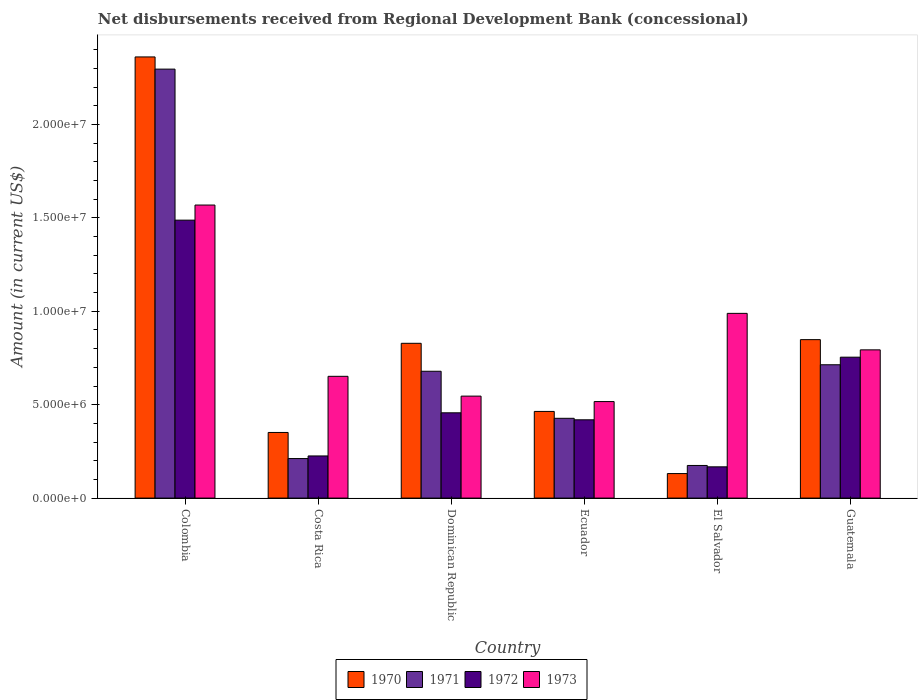How many different coloured bars are there?
Your answer should be very brief. 4. Are the number of bars per tick equal to the number of legend labels?
Your answer should be very brief. Yes. How many bars are there on the 6th tick from the left?
Ensure brevity in your answer.  4. What is the label of the 4th group of bars from the left?
Your answer should be compact. Ecuador. What is the amount of disbursements received from Regional Development Bank in 1972 in Ecuador?
Your response must be concise. 4.19e+06. Across all countries, what is the maximum amount of disbursements received from Regional Development Bank in 1971?
Keep it short and to the point. 2.30e+07. Across all countries, what is the minimum amount of disbursements received from Regional Development Bank in 1971?
Offer a very short reply. 1.75e+06. In which country was the amount of disbursements received from Regional Development Bank in 1970 minimum?
Offer a very short reply. El Salvador. What is the total amount of disbursements received from Regional Development Bank in 1973 in the graph?
Make the answer very short. 5.07e+07. What is the difference between the amount of disbursements received from Regional Development Bank in 1972 in Colombia and that in Dominican Republic?
Offer a very short reply. 1.03e+07. What is the difference between the amount of disbursements received from Regional Development Bank in 1971 in Ecuador and the amount of disbursements received from Regional Development Bank in 1972 in Dominican Republic?
Provide a short and direct response. -2.94e+05. What is the average amount of disbursements received from Regional Development Bank in 1971 per country?
Your response must be concise. 7.50e+06. What is the difference between the amount of disbursements received from Regional Development Bank of/in 1971 and amount of disbursements received from Regional Development Bank of/in 1970 in Colombia?
Make the answer very short. -6.52e+05. In how many countries, is the amount of disbursements received from Regional Development Bank in 1972 greater than 19000000 US$?
Make the answer very short. 0. What is the ratio of the amount of disbursements received from Regional Development Bank in 1970 in Colombia to that in Dominican Republic?
Your answer should be very brief. 2.85. Is the amount of disbursements received from Regional Development Bank in 1970 in Dominican Republic less than that in Guatemala?
Your answer should be compact. Yes. Is the difference between the amount of disbursements received from Regional Development Bank in 1971 in Costa Rica and Ecuador greater than the difference between the amount of disbursements received from Regional Development Bank in 1970 in Costa Rica and Ecuador?
Your answer should be compact. No. What is the difference between the highest and the second highest amount of disbursements received from Regional Development Bank in 1972?
Your response must be concise. 1.03e+07. What is the difference between the highest and the lowest amount of disbursements received from Regional Development Bank in 1972?
Your answer should be very brief. 1.32e+07. In how many countries, is the amount of disbursements received from Regional Development Bank in 1973 greater than the average amount of disbursements received from Regional Development Bank in 1973 taken over all countries?
Your answer should be compact. 2. Is it the case that in every country, the sum of the amount of disbursements received from Regional Development Bank in 1972 and amount of disbursements received from Regional Development Bank in 1970 is greater than the sum of amount of disbursements received from Regional Development Bank in 1971 and amount of disbursements received from Regional Development Bank in 1973?
Make the answer very short. No. What does the 4th bar from the right in Guatemala represents?
Provide a succinct answer. 1970. Does the graph contain any zero values?
Provide a succinct answer. No. Does the graph contain grids?
Ensure brevity in your answer.  No. Where does the legend appear in the graph?
Provide a short and direct response. Bottom center. How are the legend labels stacked?
Ensure brevity in your answer.  Horizontal. What is the title of the graph?
Make the answer very short. Net disbursements received from Regional Development Bank (concessional). Does "2003" appear as one of the legend labels in the graph?
Your answer should be very brief. No. What is the label or title of the X-axis?
Provide a short and direct response. Country. What is the Amount (in current US$) in 1970 in Colombia?
Provide a succinct answer. 2.36e+07. What is the Amount (in current US$) of 1971 in Colombia?
Offer a very short reply. 2.30e+07. What is the Amount (in current US$) of 1972 in Colombia?
Your response must be concise. 1.49e+07. What is the Amount (in current US$) of 1973 in Colombia?
Ensure brevity in your answer.  1.57e+07. What is the Amount (in current US$) of 1970 in Costa Rica?
Make the answer very short. 3.51e+06. What is the Amount (in current US$) of 1971 in Costa Rica?
Your answer should be very brief. 2.12e+06. What is the Amount (in current US$) in 1972 in Costa Rica?
Provide a succinct answer. 2.26e+06. What is the Amount (in current US$) in 1973 in Costa Rica?
Your response must be concise. 6.52e+06. What is the Amount (in current US$) in 1970 in Dominican Republic?
Provide a short and direct response. 8.29e+06. What is the Amount (in current US$) in 1971 in Dominican Republic?
Your answer should be very brief. 6.79e+06. What is the Amount (in current US$) in 1972 in Dominican Republic?
Keep it short and to the point. 4.56e+06. What is the Amount (in current US$) of 1973 in Dominican Republic?
Offer a terse response. 5.46e+06. What is the Amount (in current US$) of 1970 in Ecuador?
Give a very brief answer. 4.64e+06. What is the Amount (in current US$) in 1971 in Ecuador?
Keep it short and to the point. 4.27e+06. What is the Amount (in current US$) of 1972 in Ecuador?
Your answer should be very brief. 4.19e+06. What is the Amount (in current US$) in 1973 in Ecuador?
Ensure brevity in your answer.  5.17e+06. What is the Amount (in current US$) of 1970 in El Salvador?
Provide a succinct answer. 1.31e+06. What is the Amount (in current US$) in 1971 in El Salvador?
Provide a short and direct response. 1.75e+06. What is the Amount (in current US$) in 1972 in El Salvador?
Provide a succinct answer. 1.67e+06. What is the Amount (in current US$) in 1973 in El Salvador?
Give a very brief answer. 9.89e+06. What is the Amount (in current US$) of 1970 in Guatemala?
Your response must be concise. 8.48e+06. What is the Amount (in current US$) in 1971 in Guatemala?
Provide a short and direct response. 7.14e+06. What is the Amount (in current US$) of 1972 in Guatemala?
Offer a very short reply. 7.54e+06. What is the Amount (in current US$) in 1973 in Guatemala?
Ensure brevity in your answer.  7.94e+06. Across all countries, what is the maximum Amount (in current US$) in 1970?
Ensure brevity in your answer.  2.36e+07. Across all countries, what is the maximum Amount (in current US$) in 1971?
Offer a very short reply. 2.30e+07. Across all countries, what is the maximum Amount (in current US$) of 1972?
Your answer should be very brief. 1.49e+07. Across all countries, what is the maximum Amount (in current US$) of 1973?
Provide a short and direct response. 1.57e+07. Across all countries, what is the minimum Amount (in current US$) of 1970?
Keep it short and to the point. 1.31e+06. Across all countries, what is the minimum Amount (in current US$) of 1971?
Give a very brief answer. 1.75e+06. Across all countries, what is the minimum Amount (in current US$) in 1972?
Your answer should be compact. 1.67e+06. Across all countries, what is the minimum Amount (in current US$) in 1973?
Offer a very short reply. 5.17e+06. What is the total Amount (in current US$) of 1970 in the graph?
Your answer should be compact. 4.98e+07. What is the total Amount (in current US$) in 1971 in the graph?
Provide a short and direct response. 4.50e+07. What is the total Amount (in current US$) of 1972 in the graph?
Provide a short and direct response. 3.51e+07. What is the total Amount (in current US$) in 1973 in the graph?
Provide a succinct answer. 5.07e+07. What is the difference between the Amount (in current US$) in 1970 in Colombia and that in Costa Rica?
Your response must be concise. 2.01e+07. What is the difference between the Amount (in current US$) in 1971 in Colombia and that in Costa Rica?
Give a very brief answer. 2.08e+07. What is the difference between the Amount (in current US$) of 1972 in Colombia and that in Costa Rica?
Your answer should be very brief. 1.26e+07. What is the difference between the Amount (in current US$) of 1973 in Colombia and that in Costa Rica?
Make the answer very short. 9.17e+06. What is the difference between the Amount (in current US$) in 1970 in Colombia and that in Dominican Republic?
Ensure brevity in your answer.  1.53e+07. What is the difference between the Amount (in current US$) of 1971 in Colombia and that in Dominican Republic?
Offer a terse response. 1.62e+07. What is the difference between the Amount (in current US$) of 1972 in Colombia and that in Dominican Republic?
Make the answer very short. 1.03e+07. What is the difference between the Amount (in current US$) in 1973 in Colombia and that in Dominican Republic?
Your response must be concise. 1.02e+07. What is the difference between the Amount (in current US$) of 1970 in Colombia and that in Ecuador?
Ensure brevity in your answer.  1.90e+07. What is the difference between the Amount (in current US$) in 1971 in Colombia and that in Ecuador?
Keep it short and to the point. 1.87e+07. What is the difference between the Amount (in current US$) in 1972 in Colombia and that in Ecuador?
Offer a terse response. 1.07e+07. What is the difference between the Amount (in current US$) in 1973 in Colombia and that in Ecuador?
Offer a very short reply. 1.05e+07. What is the difference between the Amount (in current US$) of 1970 in Colombia and that in El Salvador?
Ensure brevity in your answer.  2.23e+07. What is the difference between the Amount (in current US$) of 1971 in Colombia and that in El Salvador?
Your response must be concise. 2.12e+07. What is the difference between the Amount (in current US$) in 1972 in Colombia and that in El Salvador?
Your answer should be compact. 1.32e+07. What is the difference between the Amount (in current US$) of 1973 in Colombia and that in El Salvador?
Keep it short and to the point. 5.80e+06. What is the difference between the Amount (in current US$) in 1970 in Colombia and that in Guatemala?
Your answer should be compact. 1.51e+07. What is the difference between the Amount (in current US$) in 1971 in Colombia and that in Guatemala?
Your response must be concise. 1.58e+07. What is the difference between the Amount (in current US$) of 1972 in Colombia and that in Guatemala?
Provide a short and direct response. 7.34e+06. What is the difference between the Amount (in current US$) in 1973 in Colombia and that in Guatemala?
Make the answer very short. 7.75e+06. What is the difference between the Amount (in current US$) in 1970 in Costa Rica and that in Dominican Republic?
Your response must be concise. -4.77e+06. What is the difference between the Amount (in current US$) of 1971 in Costa Rica and that in Dominican Republic?
Provide a short and direct response. -4.67e+06. What is the difference between the Amount (in current US$) of 1972 in Costa Rica and that in Dominican Republic?
Give a very brief answer. -2.31e+06. What is the difference between the Amount (in current US$) of 1973 in Costa Rica and that in Dominican Republic?
Provide a short and direct response. 1.06e+06. What is the difference between the Amount (in current US$) of 1970 in Costa Rica and that in Ecuador?
Ensure brevity in your answer.  -1.13e+06. What is the difference between the Amount (in current US$) of 1971 in Costa Rica and that in Ecuador?
Provide a short and direct response. -2.16e+06. What is the difference between the Amount (in current US$) in 1972 in Costa Rica and that in Ecuador?
Your answer should be very brief. -1.94e+06. What is the difference between the Amount (in current US$) in 1973 in Costa Rica and that in Ecuador?
Your response must be concise. 1.35e+06. What is the difference between the Amount (in current US$) of 1970 in Costa Rica and that in El Salvador?
Provide a short and direct response. 2.20e+06. What is the difference between the Amount (in current US$) in 1971 in Costa Rica and that in El Salvador?
Offer a terse response. 3.69e+05. What is the difference between the Amount (in current US$) of 1972 in Costa Rica and that in El Salvador?
Ensure brevity in your answer.  5.83e+05. What is the difference between the Amount (in current US$) of 1973 in Costa Rica and that in El Salvador?
Your answer should be compact. -3.37e+06. What is the difference between the Amount (in current US$) in 1970 in Costa Rica and that in Guatemala?
Your answer should be compact. -4.97e+06. What is the difference between the Amount (in current US$) in 1971 in Costa Rica and that in Guatemala?
Provide a succinct answer. -5.02e+06. What is the difference between the Amount (in current US$) of 1972 in Costa Rica and that in Guatemala?
Make the answer very short. -5.29e+06. What is the difference between the Amount (in current US$) in 1973 in Costa Rica and that in Guatemala?
Your response must be concise. -1.42e+06. What is the difference between the Amount (in current US$) in 1970 in Dominican Republic and that in Ecuador?
Offer a terse response. 3.65e+06. What is the difference between the Amount (in current US$) in 1971 in Dominican Republic and that in Ecuador?
Give a very brief answer. 2.52e+06. What is the difference between the Amount (in current US$) in 1972 in Dominican Republic and that in Ecuador?
Make the answer very short. 3.74e+05. What is the difference between the Amount (in current US$) in 1973 in Dominican Republic and that in Ecuador?
Ensure brevity in your answer.  2.92e+05. What is the difference between the Amount (in current US$) of 1970 in Dominican Republic and that in El Salvador?
Provide a short and direct response. 6.97e+06. What is the difference between the Amount (in current US$) of 1971 in Dominican Republic and that in El Salvador?
Your answer should be very brief. 5.04e+06. What is the difference between the Amount (in current US$) in 1972 in Dominican Republic and that in El Salvador?
Your answer should be very brief. 2.89e+06. What is the difference between the Amount (in current US$) of 1973 in Dominican Republic and that in El Salvador?
Provide a succinct answer. -4.43e+06. What is the difference between the Amount (in current US$) in 1970 in Dominican Republic and that in Guatemala?
Ensure brevity in your answer.  -1.96e+05. What is the difference between the Amount (in current US$) in 1971 in Dominican Republic and that in Guatemala?
Give a very brief answer. -3.48e+05. What is the difference between the Amount (in current US$) of 1972 in Dominican Republic and that in Guatemala?
Provide a succinct answer. -2.98e+06. What is the difference between the Amount (in current US$) in 1973 in Dominican Republic and that in Guatemala?
Keep it short and to the point. -2.48e+06. What is the difference between the Amount (in current US$) in 1970 in Ecuador and that in El Salvador?
Ensure brevity in your answer.  3.33e+06. What is the difference between the Amount (in current US$) of 1971 in Ecuador and that in El Salvador?
Your response must be concise. 2.52e+06. What is the difference between the Amount (in current US$) of 1972 in Ecuador and that in El Salvador?
Give a very brief answer. 2.52e+06. What is the difference between the Amount (in current US$) in 1973 in Ecuador and that in El Salvador?
Offer a terse response. -4.72e+06. What is the difference between the Amount (in current US$) of 1970 in Ecuador and that in Guatemala?
Make the answer very short. -3.84e+06. What is the difference between the Amount (in current US$) in 1971 in Ecuador and that in Guatemala?
Offer a terse response. -2.87e+06. What is the difference between the Amount (in current US$) in 1972 in Ecuador and that in Guatemala?
Your response must be concise. -3.35e+06. What is the difference between the Amount (in current US$) in 1973 in Ecuador and that in Guatemala?
Make the answer very short. -2.77e+06. What is the difference between the Amount (in current US$) in 1970 in El Salvador and that in Guatemala?
Your answer should be compact. -7.17e+06. What is the difference between the Amount (in current US$) of 1971 in El Salvador and that in Guatemala?
Ensure brevity in your answer.  -5.39e+06. What is the difference between the Amount (in current US$) in 1972 in El Salvador and that in Guatemala?
Offer a terse response. -5.87e+06. What is the difference between the Amount (in current US$) of 1973 in El Salvador and that in Guatemala?
Offer a very short reply. 1.95e+06. What is the difference between the Amount (in current US$) of 1970 in Colombia and the Amount (in current US$) of 1971 in Costa Rica?
Offer a very short reply. 2.15e+07. What is the difference between the Amount (in current US$) of 1970 in Colombia and the Amount (in current US$) of 1972 in Costa Rica?
Your answer should be compact. 2.14e+07. What is the difference between the Amount (in current US$) of 1970 in Colombia and the Amount (in current US$) of 1973 in Costa Rica?
Offer a very short reply. 1.71e+07. What is the difference between the Amount (in current US$) of 1971 in Colombia and the Amount (in current US$) of 1972 in Costa Rica?
Offer a very short reply. 2.07e+07. What is the difference between the Amount (in current US$) in 1971 in Colombia and the Amount (in current US$) in 1973 in Costa Rica?
Keep it short and to the point. 1.64e+07. What is the difference between the Amount (in current US$) in 1972 in Colombia and the Amount (in current US$) in 1973 in Costa Rica?
Your response must be concise. 8.36e+06. What is the difference between the Amount (in current US$) in 1970 in Colombia and the Amount (in current US$) in 1971 in Dominican Republic?
Your answer should be compact. 1.68e+07. What is the difference between the Amount (in current US$) of 1970 in Colombia and the Amount (in current US$) of 1972 in Dominican Republic?
Your answer should be compact. 1.90e+07. What is the difference between the Amount (in current US$) of 1970 in Colombia and the Amount (in current US$) of 1973 in Dominican Republic?
Give a very brief answer. 1.82e+07. What is the difference between the Amount (in current US$) of 1971 in Colombia and the Amount (in current US$) of 1972 in Dominican Republic?
Your answer should be compact. 1.84e+07. What is the difference between the Amount (in current US$) of 1971 in Colombia and the Amount (in current US$) of 1973 in Dominican Republic?
Provide a succinct answer. 1.75e+07. What is the difference between the Amount (in current US$) in 1972 in Colombia and the Amount (in current US$) in 1973 in Dominican Republic?
Make the answer very short. 9.42e+06. What is the difference between the Amount (in current US$) in 1970 in Colombia and the Amount (in current US$) in 1971 in Ecuador?
Provide a short and direct response. 1.93e+07. What is the difference between the Amount (in current US$) in 1970 in Colombia and the Amount (in current US$) in 1972 in Ecuador?
Provide a succinct answer. 1.94e+07. What is the difference between the Amount (in current US$) of 1970 in Colombia and the Amount (in current US$) of 1973 in Ecuador?
Your answer should be very brief. 1.84e+07. What is the difference between the Amount (in current US$) of 1971 in Colombia and the Amount (in current US$) of 1972 in Ecuador?
Provide a succinct answer. 1.88e+07. What is the difference between the Amount (in current US$) of 1971 in Colombia and the Amount (in current US$) of 1973 in Ecuador?
Provide a short and direct response. 1.78e+07. What is the difference between the Amount (in current US$) of 1972 in Colombia and the Amount (in current US$) of 1973 in Ecuador?
Ensure brevity in your answer.  9.71e+06. What is the difference between the Amount (in current US$) in 1970 in Colombia and the Amount (in current US$) in 1971 in El Salvador?
Your answer should be very brief. 2.19e+07. What is the difference between the Amount (in current US$) of 1970 in Colombia and the Amount (in current US$) of 1972 in El Salvador?
Your response must be concise. 2.19e+07. What is the difference between the Amount (in current US$) in 1970 in Colombia and the Amount (in current US$) in 1973 in El Salvador?
Ensure brevity in your answer.  1.37e+07. What is the difference between the Amount (in current US$) of 1971 in Colombia and the Amount (in current US$) of 1972 in El Salvador?
Your answer should be compact. 2.13e+07. What is the difference between the Amount (in current US$) of 1971 in Colombia and the Amount (in current US$) of 1973 in El Salvador?
Your answer should be very brief. 1.31e+07. What is the difference between the Amount (in current US$) of 1972 in Colombia and the Amount (in current US$) of 1973 in El Salvador?
Offer a terse response. 4.99e+06. What is the difference between the Amount (in current US$) in 1970 in Colombia and the Amount (in current US$) in 1971 in Guatemala?
Keep it short and to the point. 1.65e+07. What is the difference between the Amount (in current US$) in 1970 in Colombia and the Amount (in current US$) in 1972 in Guatemala?
Ensure brevity in your answer.  1.61e+07. What is the difference between the Amount (in current US$) in 1970 in Colombia and the Amount (in current US$) in 1973 in Guatemala?
Provide a succinct answer. 1.57e+07. What is the difference between the Amount (in current US$) in 1971 in Colombia and the Amount (in current US$) in 1972 in Guatemala?
Your answer should be very brief. 1.54e+07. What is the difference between the Amount (in current US$) in 1971 in Colombia and the Amount (in current US$) in 1973 in Guatemala?
Your answer should be compact. 1.50e+07. What is the difference between the Amount (in current US$) of 1972 in Colombia and the Amount (in current US$) of 1973 in Guatemala?
Your answer should be very brief. 6.94e+06. What is the difference between the Amount (in current US$) of 1970 in Costa Rica and the Amount (in current US$) of 1971 in Dominican Republic?
Keep it short and to the point. -3.28e+06. What is the difference between the Amount (in current US$) of 1970 in Costa Rica and the Amount (in current US$) of 1972 in Dominican Republic?
Make the answer very short. -1.05e+06. What is the difference between the Amount (in current US$) of 1970 in Costa Rica and the Amount (in current US$) of 1973 in Dominican Republic?
Offer a very short reply. -1.95e+06. What is the difference between the Amount (in current US$) of 1971 in Costa Rica and the Amount (in current US$) of 1972 in Dominican Republic?
Make the answer very short. -2.45e+06. What is the difference between the Amount (in current US$) in 1971 in Costa Rica and the Amount (in current US$) in 1973 in Dominican Republic?
Provide a short and direct response. -3.34e+06. What is the difference between the Amount (in current US$) of 1972 in Costa Rica and the Amount (in current US$) of 1973 in Dominican Republic?
Offer a terse response. -3.20e+06. What is the difference between the Amount (in current US$) in 1970 in Costa Rica and the Amount (in current US$) in 1971 in Ecuador?
Give a very brief answer. -7.58e+05. What is the difference between the Amount (in current US$) of 1970 in Costa Rica and the Amount (in current US$) of 1972 in Ecuador?
Provide a succinct answer. -6.78e+05. What is the difference between the Amount (in current US$) of 1970 in Costa Rica and the Amount (in current US$) of 1973 in Ecuador?
Keep it short and to the point. -1.65e+06. What is the difference between the Amount (in current US$) in 1971 in Costa Rica and the Amount (in current US$) in 1972 in Ecuador?
Provide a succinct answer. -2.08e+06. What is the difference between the Amount (in current US$) of 1971 in Costa Rica and the Amount (in current US$) of 1973 in Ecuador?
Make the answer very short. -3.05e+06. What is the difference between the Amount (in current US$) of 1972 in Costa Rica and the Amount (in current US$) of 1973 in Ecuador?
Offer a very short reply. -2.91e+06. What is the difference between the Amount (in current US$) of 1970 in Costa Rica and the Amount (in current US$) of 1971 in El Salvador?
Your response must be concise. 1.77e+06. What is the difference between the Amount (in current US$) of 1970 in Costa Rica and the Amount (in current US$) of 1972 in El Salvador?
Provide a short and direct response. 1.84e+06. What is the difference between the Amount (in current US$) in 1970 in Costa Rica and the Amount (in current US$) in 1973 in El Salvador?
Your answer should be very brief. -6.38e+06. What is the difference between the Amount (in current US$) in 1971 in Costa Rica and the Amount (in current US$) in 1972 in El Salvador?
Your answer should be compact. 4.43e+05. What is the difference between the Amount (in current US$) of 1971 in Costa Rica and the Amount (in current US$) of 1973 in El Salvador?
Your response must be concise. -7.77e+06. What is the difference between the Amount (in current US$) in 1972 in Costa Rica and the Amount (in current US$) in 1973 in El Salvador?
Offer a very short reply. -7.63e+06. What is the difference between the Amount (in current US$) of 1970 in Costa Rica and the Amount (in current US$) of 1971 in Guatemala?
Your answer should be very brief. -3.62e+06. What is the difference between the Amount (in current US$) in 1970 in Costa Rica and the Amount (in current US$) in 1972 in Guatemala?
Make the answer very short. -4.03e+06. What is the difference between the Amount (in current US$) in 1970 in Costa Rica and the Amount (in current US$) in 1973 in Guatemala?
Your answer should be very brief. -4.42e+06. What is the difference between the Amount (in current US$) in 1971 in Costa Rica and the Amount (in current US$) in 1972 in Guatemala?
Make the answer very short. -5.43e+06. What is the difference between the Amount (in current US$) of 1971 in Costa Rica and the Amount (in current US$) of 1973 in Guatemala?
Make the answer very short. -5.82e+06. What is the difference between the Amount (in current US$) in 1972 in Costa Rica and the Amount (in current US$) in 1973 in Guatemala?
Provide a short and direct response. -5.68e+06. What is the difference between the Amount (in current US$) in 1970 in Dominican Republic and the Amount (in current US$) in 1971 in Ecuador?
Provide a short and direct response. 4.02e+06. What is the difference between the Amount (in current US$) in 1970 in Dominican Republic and the Amount (in current US$) in 1972 in Ecuador?
Your response must be concise. 4.10e+06. What is the difference between the Amount (in current US$) of 1970 in Dominican Republic and the Amount (in current US$) of 1973 in Ecuador?
Offer a very short reply. 3.12e+06. What is the difference between the Amount (in current US$) of 1971 in Dominican Republic and the Amount (in current US$) of 1972 in Ecuador?
Give a very brief answer. 2.60e+06. What is the difference between the Amount (in current US$) of 1971 in Dominican Republic and the Amount (in current US$) of 1973 in Ecuador?
Offer a terse response. 1.62e+06. What is the difference between the Amount (in current US$) in 1972 in Dominican Republic and the Amount (in current US$) in 1973 in Ecuador?
Ensure brevity in your answer.  -6.02e+05. What is the difference between the Amount (in current US$) of 1970 in Dominican Republic and the Amount (in current US$) of 1971 in El Salvador?
Your response must be concise. 6.54e+06. What is the difference between the Amount (in current US$) of 1970 in Dominican Republic and the Amount (in current US$) of 1972 in El Salvador?
Make the answer very short. 6.61e+06. What is the difference between the Amount (in current US$) of 1970 in Dominican Republic and the Amount (in current US$) of 1973 in El Salvador?
Keep it short and to the point. -1.60e+06. What is the difference between the Amount (in current US$) of 1971 in Dominican Republic and the Amount (in current US$) of 1972 in El Salvador?
Make the answer very short. 5.12e+06. What is the difference between the Amount (in current US$) in 1971 in Dominican Republic and the Amount (in current US$) in 1973 in El Salvador?
Give a very brief answer. -3.10e+06. What is the difference between the Amount (in current US$) of 1972 in Dominican Republic and the Amount (in current US$) of 1973 in El Salvador?
Your answer should be compact. -5.32e+06. What is the difference between the Amount (in current US$) in 1970 in Dominican Republic and the Amount (in current US$) in 1971 in Guatemala?
Your answer should be compact. 1.15e+06. What is the difference between the Amount (in current US$) of 1970 in Dominican Republic and the Amount (in current US$) of 1972 in Guatemala?
Make the answer very short. 7.43e+05. What is the difference between the Amount (in current US$) in 1970 in Dominican Republic and the Amount (in current US$) in 1973 in Guatemala?
Your answer should be very brief. 3.51e+05. What is the difference between the Amount (in current US$) of 1971 in Dominican Republic and the Amount (in current US$) of 1972 in Guatemala?
Offer a very short reply. -7.54e+05. What is the difference between the Amount (in current US$) in 1971 in Dominican Republic and the Amount (in current US$) in 1973 in Guatemala?
Keep it short and to the point. -1.15e+06. What is the difference between the Amount (in current US$) in 1972 in Dominican Republic and the Amount (in current US$) in 1973 in Guatemala?
Offer a very short reply. -3.37e+06. What is the difference between the Amount (in current US$) in 1970 in Ecuador and the Amount (in current US$) in 1971 in El Salvador?
Give a very brief answer. 2.89e+06. What is the difference between the Amount (in current US$) in 1970 in Ecuador and the Amount (in current US$) in 1972 in El Salvador?
Make the answer very short. 2.97e+06. What is the difference between the Amount (in current US$) of 1970 in Ecuador and the Amount (in current US$) of 1973 in El Salvador?
Offer a terse response. -5.25e+06. What is the difference between the Amount (in current US$) of 1971 in Ecuador and the Amount (in current US$) of 1972 in El Salvador?
Keep it short and to the point. 2.60e+06. What is the difference between the Amount (in current US$) of 1971 in Ecuador and the Amount (in current US$) of 1973 in El Salvador?
Give a very brief answer. -5.62e+06. What is the difference between the Amount (in current US$) of 1972 in Ecuador and the Amount (in current US$) of 1973 in El Salvador?
Keep it short and to the point. -5.70e+06. What is the difference between the Amount (in current US$) in 1970 in Ecuador and the Amount (in current US$) in 1971 in Guatemala?
Your answer should be compact. -2.50e+06. What is the difference between the Amount (in current US$) in 1970 in Ecuador and the Amount (in current US$) in 1972 in Guatemala?
Give a very brief answer. -2.90e+06. What is the difference between the Amount (in current US$) in 1970 in Ecuador and the Amount (in current US$) in 1973 in Guatemala?
Offer a very short reply. -3.30e+06. What is the difference between the Amount (in current US$) of 1971 in Ecuador and the Amount (in current US$) of 1972 in Guatemala?
Your answer should be very brief. -3.27e+06. What is the difference between the Amount (in current US$) of 1971 in Ecuador and the Amount (in current US$) of 1973 in Guatemala?
Offer a very short reply. -3.66e+06. What is the difference between the Amount (in current US$) of 1972 in Ecuador and the Amount (in current US$) of 1973 in Guatemala?
Give a very brief answer. -3.74e+06. What is the difference between the Amount (in current US$) in 1970 in El Salvador and the Amount (in current US$) in 1971 in Guatemala?
Provide a succinct answer. -5.82e+06. What is the difference between the Amount (in current US$) in 1970 in El Salvador and the Amount (in current US$) in 1972 in Guatemala?
Keep it short and to the point. -6.23e+06. What is the difference between the Amount (in current US$) of 1970 in El Salvador and the Amount (in current US$) of 1973 in Guatemala?
Your answer should be compact. -6.62e+06. What is the difference between the Amount (in current US$) of 1971 in El Salvador and the Amount (in current US$) of 1972 in Guatemala?
Give a very brief answer. -5.80e+06. What is the difference between the Amount (in current US$) in 1971 in El Salvador and the Amount (in current US$) in 1973 in Guatemala?
Your answer should be compact. -6.19e+06. What is the difference between the Amount (in current US$) in 1972 in El Salvador and the Amount (in current US$) in 1973 in Guatemala?
Your response must be concise. -6.26e+06. What is the average Amount (in current US$) of 1970 per country?
Make the answer very short. 8.31e+06. What is the average Amount (in current US$) of 1971 per country?
Give a very brief answer. 7.50e+06. What is the average Amount (in current US$) of 1972 per country?
Your response must be concise. 5.85e+06. What is the average Amount (in current US$) of 1973 per country?
Your answer should be compact. 8.44e+06. What is the difference between the Amount (in current US$) of 1970 and Amount (in current US$) of 1971 in Colombia?
Your response must be concise. 6.52e+05. What is the difference between the Amount (in current US$) of 1970 and Amount (in current US$) of 1972 in Colombia?
Keep it short and to the point. 8.74e+06. What is the difference between the Amount (in current US$) of 1970 and Amount (in current US$) of 1973 in Colombia?
Your response must be concise. 7.93e+06. What is the difference between the Amount (in current US$) in 1971 and Amount (in current US$) in 1972 in Colombia?
Provide a short and direct response. 8.08e+06. What is the difference between the Amount (in current US$) of 1971 and Amount (in current US$) of 1973 in Colombia?
Your answer should be very brief. 7.28e+06. What is the difference between the Amount (in current US$) in 1972 and Amount (in current US$) in 1973 in Colombia?
Your response must be concise. -8.09e+05. What is the difference between the Amount (in current US$) in 1970 and Amount (in current US$) in 1971 in Costa Rica?
Offer a very short reply. 1.40e+06. What is the difference between the Amount (in current US$) of 1970 and Amount (in current US$) of 1972 in Costa Rica?
Make the answer very short. 1.26e+06. What is the difference between the Amount (in current US$) of 1970 and Amount (in current US$) of 1973 in Costa Rica?
Offer a terse response. -3.00e+06. What is the difference between the Amount (in current US$) of 1971 and Amount (in current US$) of 1973 in Costa Rica?
Give a very brief answer. -4.40e+06. What is the difference between the Amount (in current US$) of 1972 and Amount (in current US$) of 1973 in Costa Rica?
Your answer should be very brief. -4.26e+06. What is the difference between the Amount (in current US$) in 1970 and Amount (in current US$) in 1971 in Dominican Republic?
Your response must be concise. 1.50e+06. What is the difference between the Amount (in current US$) in 1970 and Amount (in current US$) in 1972 in Dominican Republic?
Offer a very short reply. 3.72e+06. What is the difference between the Amount (in current US$) of 1970 and Amount (in current US$) of 1973 in Dominican Republic?
Ensure brevity in your answer.  2.83e+06. What is the difference between the Amount (in current US$) of 1971 and Amount (in current US$) of 1972 in Dominican Republic?
Keep it short and to the point. 2.22e+06. What is the difference between the Amount (in current US$) of 1971 and Amount (in current US$) of 1973 in Dominican Republic?
Provide a short and direct response. 1.33e+06. What is the difference between the Amount (in current US$) in 1972 and Amount (in current US$) in 1973 in Dominican Republic?
Keep it short and to the point. -8.94e+05. What is the difference between the Amount (in current US$) of 1970 and Amount (in current US$) of 1971 in Ecuador?
Your response must be concise. 3.68e+05. What is the difference between the Amount (in current US$) in 1970 and Amount (in current US$) in 1972 in Ecuador?
Provide a succinct answer. 4.48e+05. What is the difference between the Amount (in current US$) of 1970 and Amount (in current US$) of 1973 in Ecuador?
Offer a very short reply. -5.28e+05. What is the difference between the Amount (in current US$) in 1971 and Amount (in current US$) in 1972 in Ecuador?
Provide a succinct answer. 8.00e+04. What is the difference between the Amount (in current US$) in 1971 and Amount (in current US$) in 1973 in Ecuador?
Your response must be concise. -8.96e+05. What is the difference between the Amount (in current US$) in 1972 and Amount (in current US$) in 1973 in Ecuador?
Provide a succinct answer. -9.76e+05. What is the difference between the Amount (in current US$) in 1970 and Amount (in current US$) in 1971 in El Salvador?
Your answer should be compact. -4.34e+05. What is the difference between the Amount (in current US$) in 1970 and Amount (in current US$) in 1972 in El Salvador?
Ensure brevity in your answer.  -3.60e+05. What is the difference between the Amount (in current US$) in 1970 and Amount (in current US$) in 1973 in El Salvador?
Your response must be concise. -8.58e+06. What is the difference between the Amount (in current US$) in 1971 and Amount (in current US$) in 1972 in El Salvador?
Keep it short and to the point. 7.40e+04. What is the difference between the Amount (in current US$) in 1971 and Amount (in current US$) in 1973 in El Salvador?
Ensure brevity in your answer.  -8.14e+06. What is the difference between the Amount (in current US$) in 1972 and Amount (in current US$) in 1973 in El Salvador?
Keep it short and to the point. -8.22e+06. What is the difference between the Amount (in current US$) of 1970 and Amount (in current US$) of 1971 in Guatemala?
Your answer should be very brief. 1.34e+06. What is the difference between the Amount (in current US$) of 1970 and Amount (in current US$) of 1972 in Guatemala?
Ensure brevity in your answer.  9.39e+05. What is the difference between the Amount (in current US$) in 1970 and Amount (in current US$) in 1973 in Guatemala?
Ensure brevity in your answer.  5.47e+05. What is the difference between the Amount (in current US$) of 1971 and Amount (in current US$) of 1972 in Guatemala?
Offer a very short reply. -4.06e+05. What is the difference between the Amount (in current US$) in 1971 and Amount (in current US$) in 1973 in Guatemala?
Make the answer very short. -7.98e+05. What is the difference between the Amount (in current US$) in 1972 and Amount (in current US$) in 1973 in Guatemala?
Provide a succinct answer. -3.92e+05. What is the ratio of the Amount (in current US$) in 1970 in Colombia to that in Costa Rica?
Offer a very short reply. 6.72. What is the ratio of the Amount (in current US$) in 1971 in Colombia to that in Costa Rica?
Your answer should be very brief. 10.85. What is the ratio of the Amount (in current US$) in 1972 in Colombia to that in Costa Rica?
Give a very brief answer. 6.59. What is the ratio of the Amount (in current US$) in 1973 in Colombia to that in Costa Rica?
Offer a terse response. 2.41. What is the ratio of the Amount (in current US$) of 1970 in Colombia to that in Dominican Republic?
Offer a terse response. 2.85. What is the ratio of the Amount (in current US$) of 1971 in Colombia to that in Dominican Republic?
Give a very brief answer. 3.38. What is the ratio of the Amount (in current US$) in 1972 in Colombia to that in Dominican Republic?
Give a very brief answer. 3.26. What is the ratio of the Amount (in current US$) in 1973 in Colombia to that in Dominican Republic?
Provide a succinct answer. 2.87. What is the ratio of the Amount (in current US$) of 1970 in Colombia to that in Ecuador?
Make the answer very short. 5.09. What is the ratio of the Amount (in current US$) of 1971 in Colombia to that in Ecuador?
Your answer should be very brief. 5.38. What is the ratio of the Amount (in current US$) in 1972 in Colombia to that in Ecuador?
Offer a very short reply. 3.55. What is the ratio of the Amount (in current US$) in 1973 in Colombia to that in Ecuador?
Provide a short and direct response. 3.04. What is the ratio of the Amount (in current US$) in 1970 in Colombia to that in El Salvador?
Ensure brevity in your answer.  17.99. What is the ratio of the Amount (in current US$) of 1971 in Colombia to that in El Salvador?
Offer a terse response. 13.14. What is the ratio of the Amount (in current US$) in 1972 in Colombia to that in El Salvador?
Keep it short and to the point. 8.89. What is the ratio of the Amount (in current US$) of 1973 in Colombia to that in El Salvador?
Ensure brevity in your answer.  1.59. What is the ratio of the Amount (in current US$) of 1970 in Colombia to that in Guatemala?
Keep it short and to the point. 2.78. What is the ratio of the Amount (in current US$) of 1971 in Colombia to that in Guatemala?
Ensure brevity in your answer.  3.22. What is the ratio of the Amount (in current US$) in 1972 in Colombia to that in Guatemala?
Make the answer very short. 1.97. What is the ratio of the Amount (in current US$) of 1973 in Colombia to that in Guatemala?
Offer a terse response. 1.98. What is the ratio of the Amount (in current US$) in 1970 in Costa Rica to that in Dominican Republic?
Provide a succinct answer. 0.42. What is the ratio of the Amount (in current US$) in 1971 in Costa Rica to that in Dominican Republic?
Give a very brief answer. 0.31. What is the ratio of the Amount (in current US$) of 1972 in Costa Rica to that in Dominican Republic?
Give a very brief answer. 0.49. What is the ratio of the Amount (in current US$) of 1973 in Costa Rica to that in Dominican Republic?
Your response must be concise. 1.19. What is the ratio of the Amount (in current US$) in 1970 in Costa Rica to that in Ecuador?
Give a very brief answer. 0.76. What is the ratio of the Amount (in current US$) of 1971 in Costa Rica to that in Ecuador?
Provide a succinct answer. 0.5. What is the ratio of the Amount (in current US$) of 1972 in Costa Rica to that in Ecuador?
Provide a short and direct response. 0.54. What is the ratio of the Amount (in current US$) of 1973 in Costa Rica to that in Ecuador?
Provide a succinct answer. 1.26. What is the ratio of the Amount (in current US$) in 1970 in Costa Rica to that in El Salvador?
Give a very brief answer. 2.68. What is the ratio of the Amount (in current US$) in 1971 in Costa Rica to that in El Salvador?
Give a very brief answer. 1.21. What is the ratio of the Amount (in current US$) of 1972 in Costa Rica to that in El Salvador?
Offer a terse response. 1.35. What is the ratio of the Amount (in current US$) in 1973 in Costa Rica to that in El Salvador?
Offer a very short reply. 0.66. What is the ratio of the Amount (in current US$) in 1970 in Costa Rica to that in Guatemala?
Provide a short and direct response. 0.41. What is the ratio of the Amount (in current US$) in 1971 in Costa Rica to that in Guatemala?
Ensure brevity in your answer.  0.3. What is the ratio of the Amount (in current US$) in 1972 in Costa Rica to that in Guatemala?
Make the answer very short. 0.3. What is the ratio of the Amount (in current US$) of 1973 in Costa Rica to that in Guatemala?
Your response must be concise. 0.82. What is the ratio of the Amount (in current US$) of 1970 in Dominican Republic to that in Ecuador?
Provide a short and direct response. 1.79. What is the ratio of the Amount (in current US$) of 1971 in Dominican Republic to that in Ecuador?
Provide a short and direct response. 1.59. What is the ratio of the Amount (in current US$) of 1972 in Dominican Republic to that in Ecuador?
Your response must be concise. 1.09. What is the ratio of the Amount (in current US$) in 1973 in Dominican Republic to that in Ecuador?
Give a very brief answer. 1.06. What is the ratio of the Amount (in current US$) of 1970 in Dominican Republic to that in El Salvador?
Make the answer very short. 6.31. What is the ratio of the Amount (in current US$) of 1971 in Dominican Republic to that in El Salvador?
Provide a short and direct response. 3.89. What is the ratio of the Amount (in current US$) of 1972 in Dominican Republic to that in El Salvador?
Keep it short and to the point. 2.73. What is the ratio of the Amount (in current US$) in 1973 in Dominican Republic to that in El Salvador?
Make the answer very short. 0.55. What is the ratio of the Amount (in current US$) in 1970 in Dominican Republic to that in Guatemala?
Ensure brevity in your answer.  0.98. What is the ratio of the Amount (in current US$) in 1971 in Dominican Republic to that in Guatemala?
Your response must be concise. 0.95. What is the ratio of the Amount (in current US$) of 1972 in Dominican Republic to that in Guatemala?
Ensure brevity in your answer.  0.61. What is the ratio of the Amount (in current US$) in 1973 in Dominican Republic to that in Guatemala?
Give a very brief answer. 0.69. What is the ratio of the Amount (in current US$) of 1970 in Ecuador to that in El Salvador?
Offer a terse response. 3.53. What is the ratio of the Amount (in current US$) of 1971 in Ecuador to that in El Salvador?
Your response must be concise. 2.44. What is the ratio of the Amount (in current US$) in 1972 in Ecuador to that in El Salvador?
Your response must be concise. 2.51. What is the ratio of the Amount (in current US$) of 1973 in Ecuador to that in El Salvador?
Keep it short and to the point. 0.52. What is the ratio of the Amount (in current US$) of 1970 in Ecuador to that in Guatemala?
Ensure brevity in your answer.  0.55. What is the ratio of the Amount (in current US$) in 1971 in Ecuador to that in Guatemala?
Your response must be concise. 0.6. What is the ratio of the Amount (in current US$) in 1972 in Ecuador to that in Guatemala?
Your answer should be compact. 0.56. What is the ratio of the Amount (in current US$) of 1973 in Ecuador to that in Guatemala?
Your response must be concise. 0.65. What is the ratio of the Amount (in current US$) of 1970 in El Salvador to that in Guatemala?
Ensure brevity in your answer.  0.15. What is the ratio of the Amount (in current US$) of 1971 in El Salvador to that in Guatemala?
Provide a succinct answer. 0.24. What is the ratio of the Amount (in current US$) of 1972 in El Salvador to that in Guatemala?
Provide a short and direct response. 0.22. What is the ratio of the Amount (in current US$) in 1973 in El Salvador to that in Guatemala?
Provide a short and direct response. 1.25. What is the difference between the highest and the second highest Amount (in current US$) in 1970?
Your answer should be compact. 1.51e+07. What is the difference between the highest and the second highest Amount (in current US$) of 1971?
Offer a very short reply. 1.58e+07. What is the difference between the highest and the second highest Amount (in current US$) in 1972?
Provide a short and direct response. 7.34e+06. What is the difference between the highest and the second highest Amount (in current US$) of 1973?
Give a very brief answer. 5.80e+06. What is the difference between the highest and the lowest Amount (in current US$) in 1970?
Provide a succinct answer. 2.23e+07. What is the difference between the highest and the lowest Amount (in current US$) of 1971?
Provide a succinct answer. 2.12e+07. What is the difference between the highest and the lowest Amount (in current US$) in 1972?
Your answer should be compact. 1.32e+07. What is the difference between the highest and the lowest Amount (in current US$) of 1973?
Keep it short and to the point. 1.05e+07. 